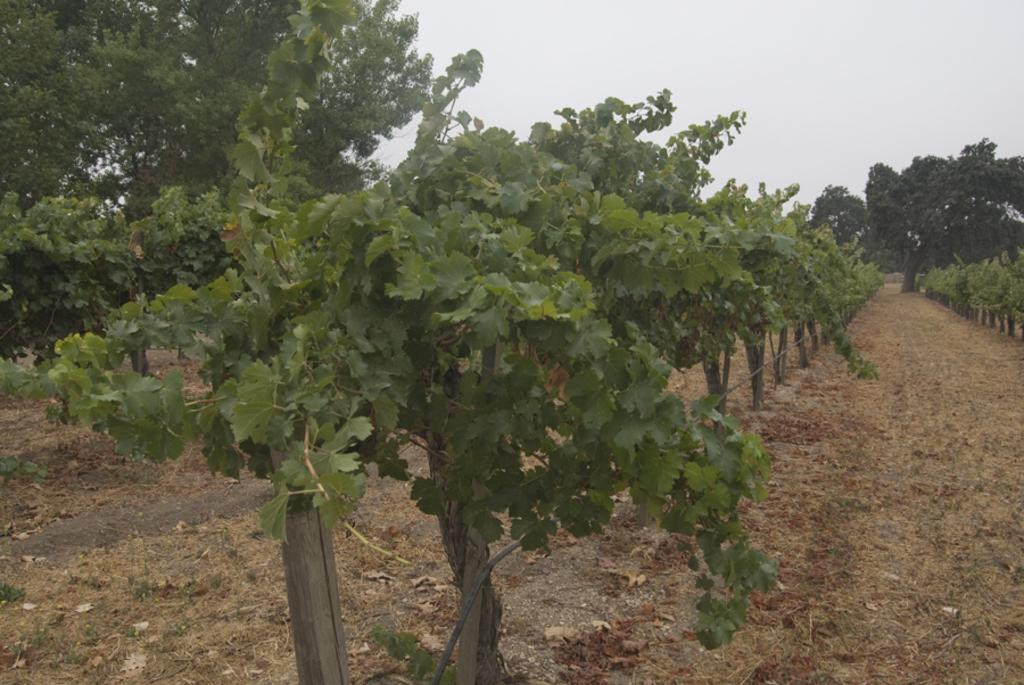What type of living organisms can be seen in the image? Plants can be seen in the image. What kind of path is visible in the image? There is a walkway in the image. What can be seen in the background of the image? Trees are visible in the background of the image. What type of stocking is the farmer wearing in the image? There is no farmer or stocking present in the image. 